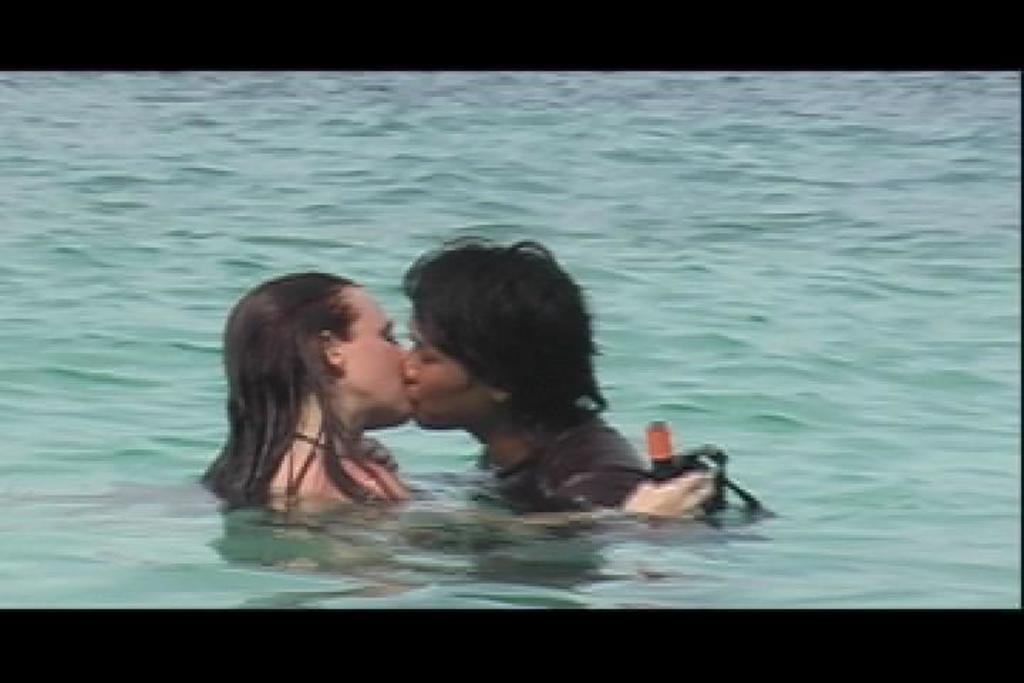What is visible in the image? There is water visible in the image, and there is a man and a woman in the water. What are the man and woman doing in the water? The man and woman are kissing in the water. What is the woman holding in her hand? The woman is holding a black color object in her hand. Who is coaching the man and woman in the water? There is no coach present in the image. What is the relationship between the man and the woman holding the black object? The relationship between the man and the woman is not specified in the image. 